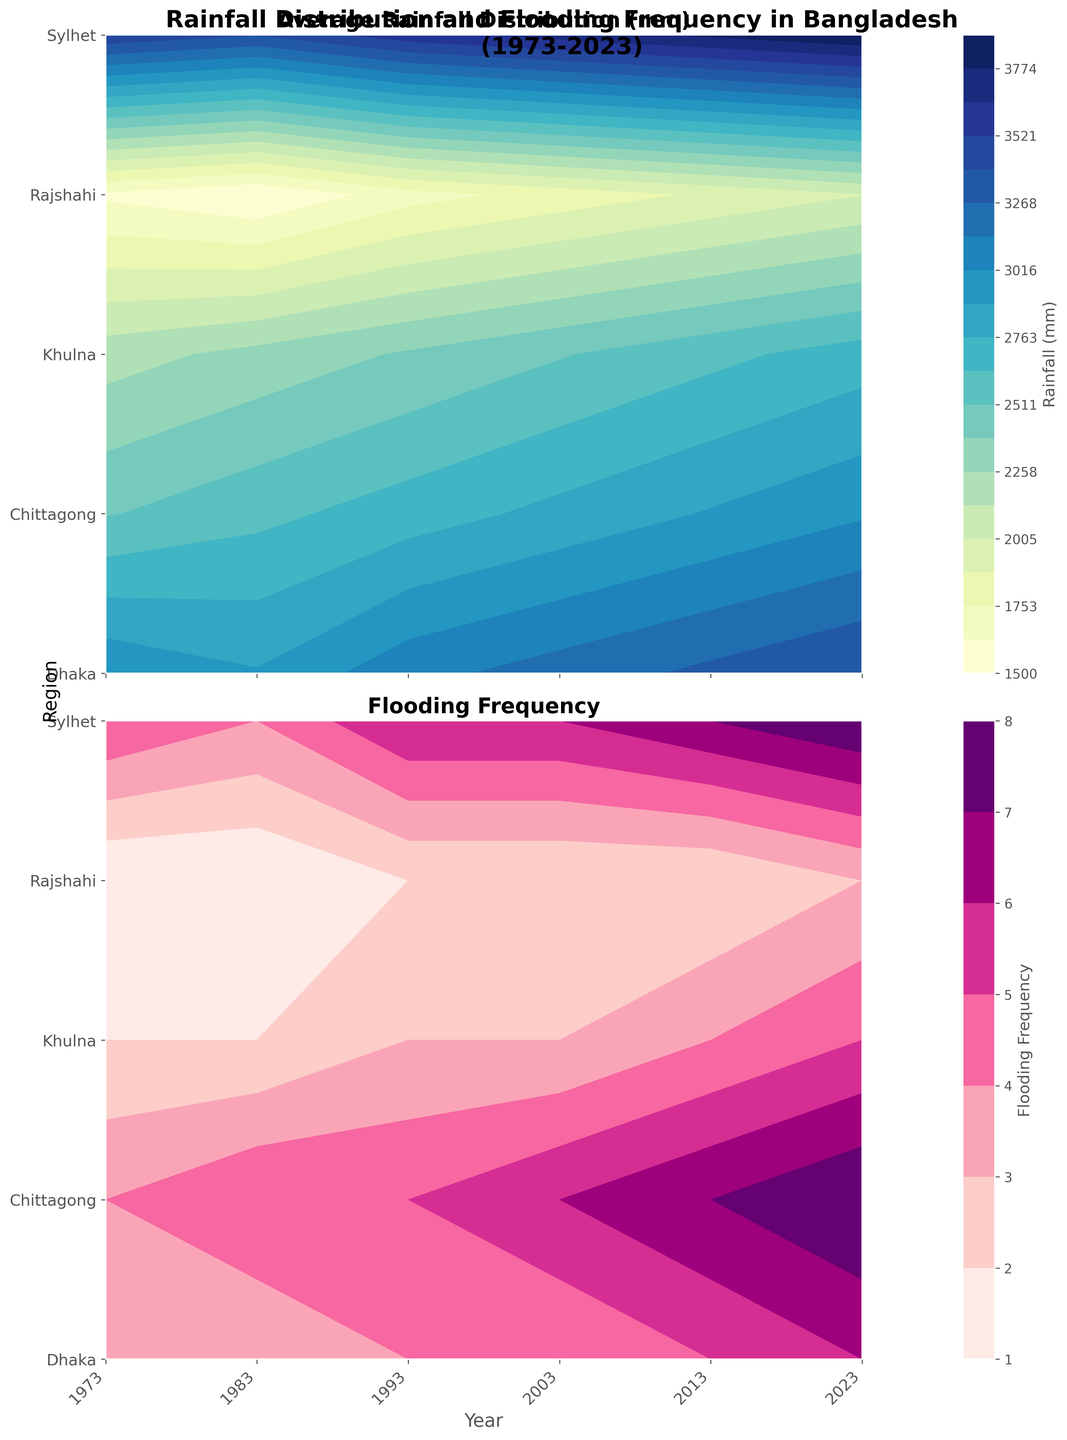Does the plot show an increasing trend in rainfall and flooding over time? To answer this, observe the contour plots for any notable changes in color intensity and contour levels over the years. Both the rainfall and flooding plots have darker/more intense colors in recent years, indicating an increase.
Answer: Yes Which region experienced the highest average rainfall in 2023? Look at the darkest shades in the 2023 column of the rainfall plot. Sylhet has the darkest color, indicating the highest rainfall.
Answer: Sylhet How many regions experienced increased flooding frequency between 1973 and 2023? Compare the colors in the flooding frequency plot for each region from 1973 to 2023. All regions show a darker shade in 2023 compared to 1973, indicative of increased frequency.
Answer: 5 In which year did Dhaka experience the most flooding? Identify the year with the darkest color for Dhaka in the flooding frequency plot. The year 2023 has the darkest color.
Answer: 2023 Did the average rainfall in Chittagong ever decrease over the 50 years? Observe the shades of color in the rainfall plot for Chittagong across the years. The color slightly decreases from 1973 to 1983, then consistently increases.
Answer: Yes Which region shows the least variability in rainfall over the 50 years? Look for the region where the color variation is minimal in the rainfall plot. Rajshahi shows the least variation in color.
Answer: Rajshahi Compare the flooding frequency in Dhaka and Sylhet in 2013. Which had more? In the flooding frequency plot for the year 2013, Sylhet's color is darker than Dhaka's, indicating a higher frequency.
Answer: Sylhet What's the trend in average rainfall for Khulna from 1973 to 2023? Examine the color gradient in the rainfall plot for Khulna from 1973 to 2023. The intensity of the color gradually increases, indicating a rising trend.
Answer: Increasing Between 1993 and 2003, which region had the most significant increase in flooding frequency? Observe the change in color intensity between 1993 and 2003 in the flooding frequency plot for each region. Dhaka shows the most significant color change.
Answer: Dhaka 